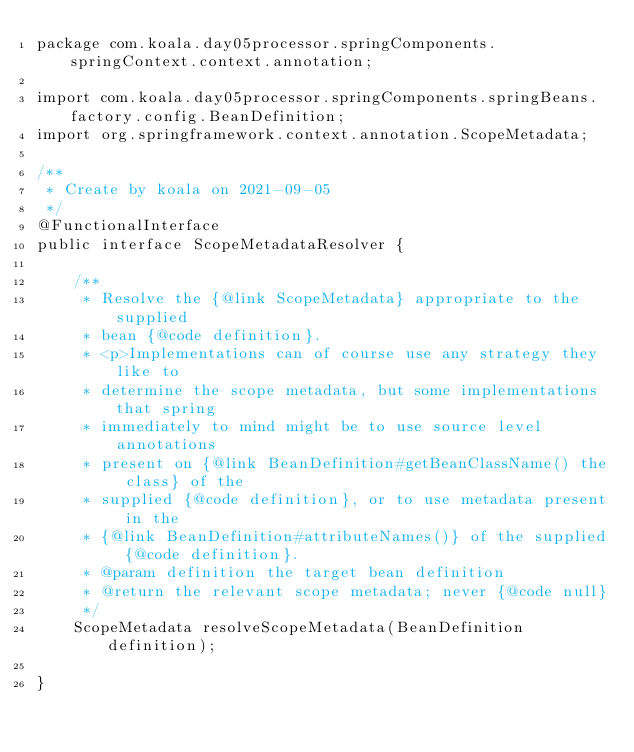Convert code to text. <code><loc_0><loc_0><loc_500><loc_500><_Java_>package com.koala.day05processor.springComponents.springContext.context.annotation;

import com.koala.day05processor.springComponents.springBeans.factory.config.BeanDefinition;
import org.springframework.context.annotation.ScopeMetadata;

/**
 * Create by koala on 2021-09-05
 */
@FunctionalInterface
public interface ScopeMetadataResolver {

    /**
     * Resolve the {@link ScopeMetadata} appropriate to the supplied
     * bean {@code definition}.
     * <p>Implementations can of course use any strategy they like to
     * determine the scope metadata, but some implementations that spring
     * immediately to mind might be to use source level annotations
     * present on {@link BeanDefinition#getBeanClassName() the class} of the
     * supplied {@code definition}, or to use metadata present in the
     * {@link BeanDefinition#attributeNames()} of the supplied {@code definition}.
     * @param definition the target bean definition
     * @return the relevant scope metadata; never {@code null}
     */
    ScopeMetadata resolveScopeMetadata(BeanDefinition definition);

}
</code> 